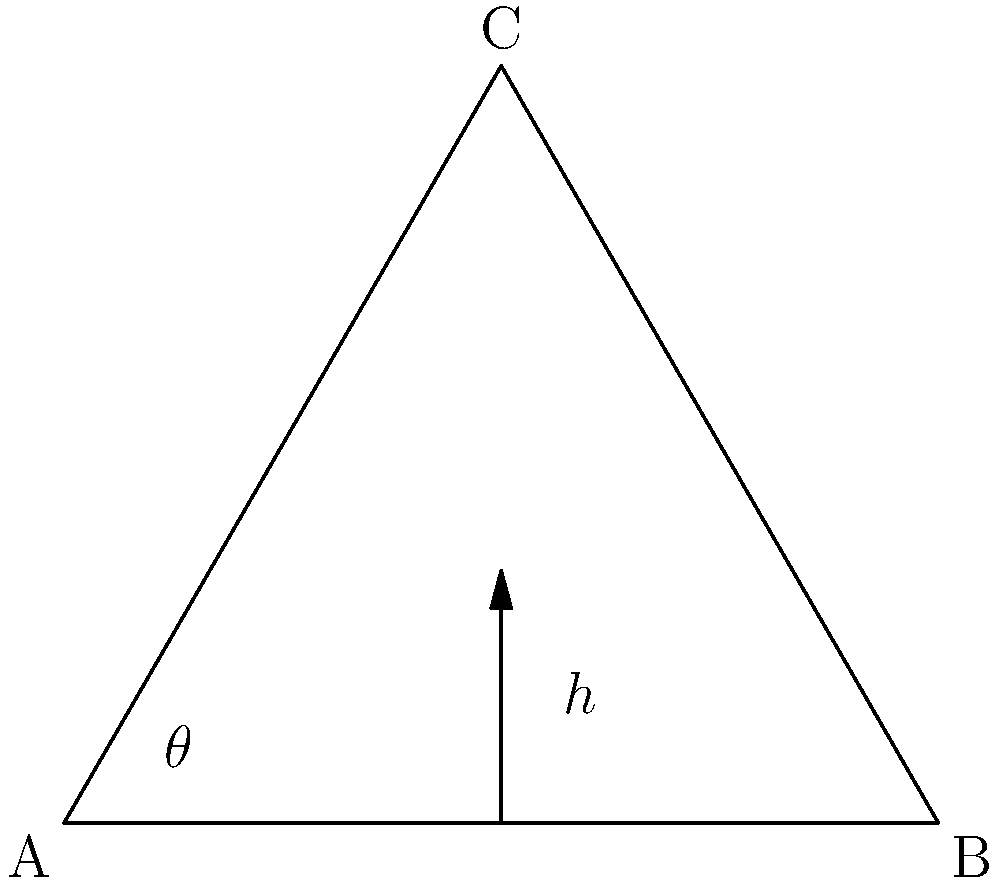In Baroque portraiture, the gestures and poses often involve raised arms. Consider a simplified model of an arm as a triangle ABC, where AB represents the upper arm and BC the forearm. If the angle $\theta$ between the upper arm and the vertical is 30°, and the lengths of AB and BC are both 50 cm, what is the vertical height (h) of point C above the horizontal line AB? To solve this problem, we'll follow these steps:

1. Recognize that we're dealing with an equilateral triangle (since AB = BC = 50 cm).

2. In an equilateral triangle, all angles are 60°. This means the angle between BC and the vertical is also 30° (as 90° - 60° = 30°).

3. The height h we're looking for is the sum of the vertical components of AB and BC.

4. For AB:
   - The vertical component is $AB \cos(\theta)$
   - $AB \cos(30°) = 50 \cdot \frac{\sqrt{3}}{2} \approx 43.3$ cm

5. For BC:
   - The vertical component is also $BC \cos(30°)$
   - This is the same as for AB: $50 \cdot \frac{\sqrt{3}}{2} \approx 43.3$ cm

6. The total height h is the sum of these two components:
   $h = 2 \cdot 50 \cdot \frac{\sqrt{3}}{2} = 50\sqrt{3} \approx 86.6$ cm

Therefore, the vertical height of point C above the horizontal line AB is $50\sqrt{3}$ cm or approximately 86.6 cm.
Answer: $50\sqrt{3}$ cm 